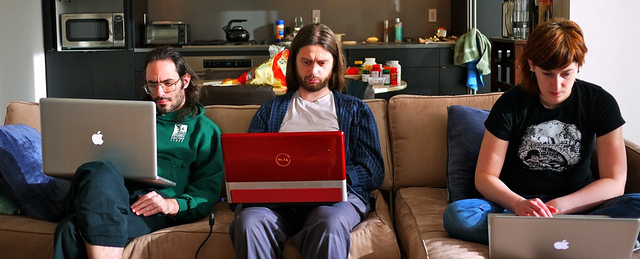Extract all visible text content from this image. DELL 